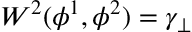<formula> <loc_0><loc_0><loc_500><loc_500>W ^ { 2 } ( \phi ^ { 1 } , \phi ^ { 2 } ) = \gamma _ { \perp }</formula> 